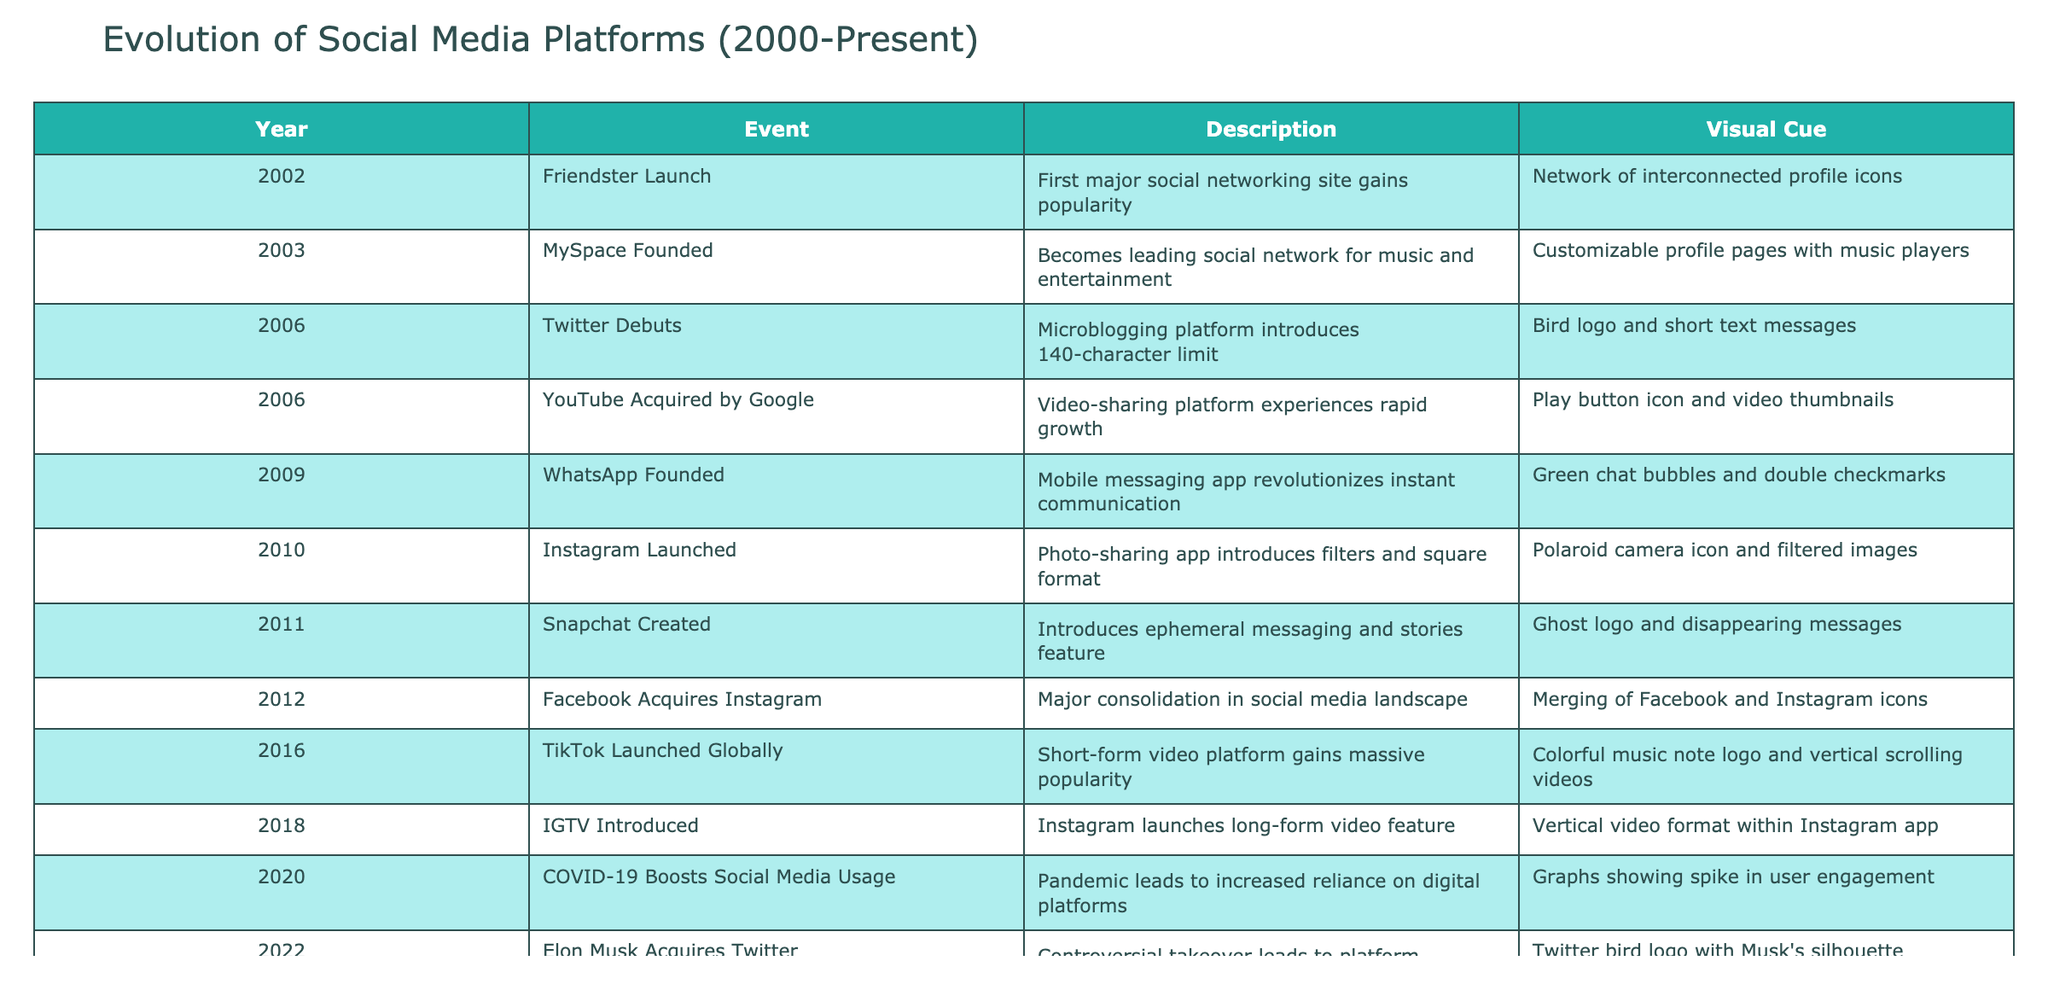What year did Facebook acquire Instagram? The table shows the event for Facebook acquiring Instagram in 2012. By checking the 'Year' column corresponding to that event, we find the answer.
Answer: 2012 Which social media platform was launched first, Twitter or Instagram? By reviewing the 'Year' column, Twitter was launched in 2006 and Instagram in 2010. Since 2006 comes before 2010, Twitter was launched first.
Answer: Twitter How many years passed between the launch of WhatsApp and TikTok? WhatsApp was founded in 2009 and TikTok was launched in 2016. To calculate the difference, we subtract the two years (2016 - 2009) which equals 7 years.
Answer: 7 years Was the introduction of IGTV in 2018 the first major video feature added to Instagram? The table states that Instagram was launched in 2010, which introduced photo sharing. However, YouTube was acquired by Google in 2006 and has its own video features not related to Instagram. IGTV is a significant feature, but it was not the first video-related feature of Instagram or social media as a whole.
Answer: No Which event mentions a significant increase in social media usage? The event in 2020 details the impact of COVID-19, highlighting a boost in social media usage during the pandemic. Searching the event descriptions confirms this trend.
Answer: COVID-19 Boosts Social Media Usage What is the total number of major social media platforms mentioned that were launched or acquired up to 2016? The platforms launched or acquired before and including 2016 are Friendster, MySpace, Twitter, YouTube, WhatsApp, Instagram, Snapchat, and TikTok. Counting these reveals a total of 8 major platforms.
Answer: 8 platforms Which two events occurred in the same year, and what were they? The table shows that Twitter debuted and YouTube was acquired by Google, both in 2006. By examining the events and their corresponding years, we can confirm.
Answer: Twitter and YouTube were both in 2006 What visual cue represents the launch of Snapchat? The table's visual cue column shows the ghost logo and disappearing messages correspond to the launch of Snapchat in 2011. This can be confirmed by checking the event description.
Answer: Ghost logo and disappearing messages What was the event that led to a controversial takeover in 2022? The event described for 2022 states that Elon Musk acquired Twitter, which is labeled as a controversial takeover in the description, thus providing the answer.
Answer: Elon Musk Acquires Twitter 